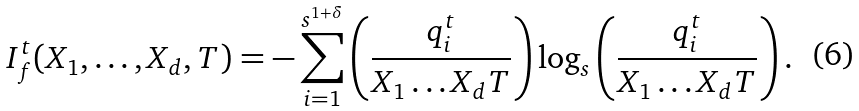<formula> <loc_0><loc_0><loc_500><loc_500>I _ { f } ^ { t } ( X _ { 1 } , \dots , X _ { d } , T ) = - \sum _ { i = 1 } ^ { s ^ { 1 + \delta } } \left ( \frac { q _ { i } ^ { t } } { X _ { 1 } \dots X _ { d } T } \right ) \log _ { s } \left ( \frac { q _ { i } ^ { t } } { X _ { 1 } \dots X _ { d } T } \right ) .</formula> 